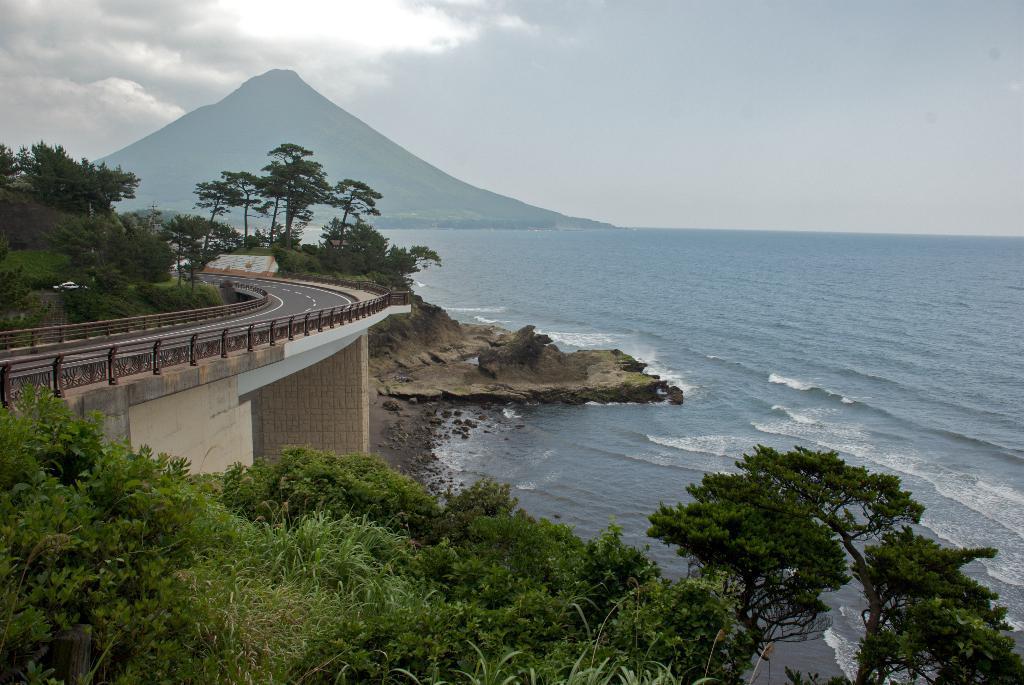Please provide a concise description of this image. Sky is cloudy. Here we can see trees, bridge and water. Far there is a mountain. 